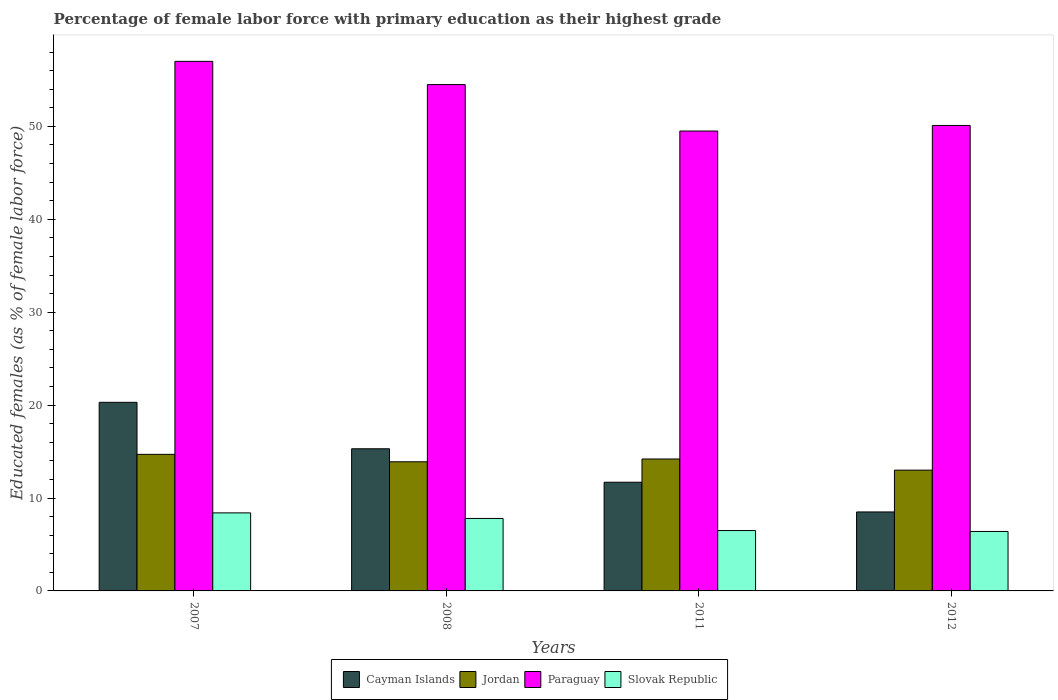How many different coloured bars are there?
Keep it short and to the point. 4. How many groups of bars are there?
Provide a succinct answer. 4. Are the number of bars per tick equal to the number of legend labels?
Provide a succinct answer. Yes. Are the number of bars on each tick of the X-axis equal?
Provide a succinct answer. Yes. How many bars are there on the 2nd tick from the left?
Provide a succinct answer. 4. In how many cases, is the number of bars for a given year not equal to the number of legend labels?
Your answer should be very brief. 0. Across all years, what is the maximum percentage of female labor force with primary education in Slovak Republic?
Your answer should be very brief. 8.4. Across all years, what is the minimum percentage of female labor force with primary education in Paraguay?
Ensure brevity in your answer.  49.5. In which year was the percentage of female labor force with primary education in Paraguay maximum?
Provide a succinct answer. 2007. What is the total percentage of female labor force with primary education in Slovak Republic in the graph?
Your response must be concise. 29.1. What is the difference between the percentage of female labor force with primary education in Jordan in 2007 and that in 2011?
Offer a very short reply. 0.5. What is the difference between the percentage of female labor force with primary education in Jordan in 2011 and the percentage of female labor force with primary education in Cayman Islands in 2007?
Your answer should be compact. -6.1. What is the average percentage of female labor force with primary education in Paraguay per year?
Offer a very short reply. 52.77. In the year 2007, what is the difference between the percentage of female labor force with primary education in Slovak Republic and percentage of female labor force with primary education in Paraguay?
Provide a succinct answer. -48.6. In how many years, is the percentage of female labor force with primary education in Jordan greater than 30 %?
Your answer should be very brief. 0. What is the ratio of the percentage of female labor force with primary education in Slovak Republic in 2008 to that in 2011?
Provide a succinct answer. 1.2. Is the percentage of female labor force with primary education in Slovak Republic in 2011 less than that in 2012?
Your response must be concise. No. Is the difference between the percentage of female labor force with primary education in Slovak Republic in 2007 and 2011 greater than the difference between the percentage of female labor force with primary education in Paraguay in 2007 and 2011?
Your answer should be compact. No. What is the difference between the highest and the second highest percentage of female labor force with primary education in Jordan?
Give a very brief answer. 0.5. What is the difference between the highest and the lowest percentage of female labor force with primary education in Slovak Republic?
Ensure brevity in your answer.  2. Is the sum of the percentage of female labor force with primary education in Slovak Republic in 2007 and 2008 greater than the maximum percentage of female labor force with primary education in Jordan across all years?
Your answer should be very brief. Yes. Is it the case that in every year, the sum of the percentage of female labor force with primary education in Slovak Republic and percentage of female labor force with primary education in Jordan is greater than the sum of percentage of female labor force with primary education in Paraguay and percentage of female labor force with primary education in Cayman Islands?
Provide a short and direct response. No. What does the 1st bar from the left in 2012 represents?
Give a very brief answer. Cayman Islands. What does the 3rd bar from the right in 2012 represents?
Your answer should be compact. Jordan. Is it the case that in every year, the sum of the percentage of female labor force with primary education in Paraguay and percentage of female labor force with primary education in Cayman Islands is greater than the percentage of female labor force with primary education in Slovak Republic?
Your answer should be very brief. Yes. Does the graph contain any zero values?
Offer a very short reply. No. What is the title of the graph?
Your answer should be very brief. Percentage of female labor force with primary education as their highest grade. Does "Philippines" appear as one of the legend labels in the graph?
Offer a very short reply. No. What is the label or title of the Y-axis?
Provide a short and direct response. Educated females (as % of female labor force). What is the Educated females (as % of female labor force) of Cayman Islands in 2007?
Keep it short and to the point. 20.3. What is the Educated females (as % of female labor force) in Jordan in 2007?
Your response must be concise. 14.7. What is the Educated females (as % of female labor force) in Paraguay in 2007?
Your answer should be compact. 57. What is the Educated females (as % of female labor force) in Slovak Republic in 2007?
Provide a short and direct response. 8.4. What is the Educated females (as % of female labor force) in Cayman Islands in 2008?
Your response must be concise. 15.3. What is the Educated females (as % of female labor force) of Jordan in 2008?
Offer a very short reply. 13.9. What is the Educated females (as % of female labor force) of Paraguay in 2008?
Give a very brief answer. 54.5. What is the Educated females (as % of female labor force) of Slovak Republic in 2008?
Offer a very short reply. 7.8. What is the Educated females (as % of female labor force) of Cayman Islands in 2011?
Your answer should be very brief. 11.7. What is the Educated females (as % of female labor force) of Jordan in 2011?
Offer a very short reply. 14.2. What is the Educated females (as % of female labor force) in Paraguay in 2011?
Your answer should be very brief. 49.5. What is the Educated females (as % of female labor force) of Slovak Republic in 2011?
Give a very brief answer. 6.5. What is the Educated females (as % of female labor force) of Jordan in 2012?
Ensure brevity in your answer.  13. What is the Educated females (as % of female labor force) of Paraguay in 2012?
Your answer should be compact. 50.1. What is the Educated females (as % of female labor force) in Slovak Republic in 2012?
Ensure brevity in your answer.  6.4. Across all years, what is the maximum Educated females (as % of female labor force) of Cayman Islands?
Provide a succinct answer. 20.3. Across all years, what is the maximum Educated females (as % of female labor force) in Jordan?
Your answer should be compact. 14.7. Across all years, what is the maximum Educated females (as % of female labor force) of Slovak Republic?
Provide a short and direct response. 8.4. Across all years, what is the minimum Educated females (as % of female labor force) in Paraguay?
Keep it short and to the point. 49.5. Across all years, what is the minimum Educated females (as % of female labor force) of Slovak Republic?
Your answer should be compact. 6.4. What is the total Educated females (as % of female labor force) in Cayman Islands in the graph?
Offer a very short reply. 55.8. What is the total Educated females (as % of female labor force) in Jordan in the graph?
Keep it short and to the point. 55.8. What is the total Educated females (as % of female labor force) of Paraguay in the graph?
Provide a succinct answer. 211.1. What is the total Educated females (as % of female labor force) in Slovak Republic in the graph?
Ensure brevity in your answer.  29.1. What is the difference between the Educated females (as % of female labor force) of Paraguay in 2007 and that in 2008?
Provide a short and direct response. 2.5. What is the difference between the Educated females (as % of female labor force) of Cayman Islands in 2007 and that in 2011?
Your answer should be very brief. 8.6. What is the difference between the Educated females (as % of female labor force) of Jordan in 2007 and that in 2011?
Keep it short and to the point. 0.5. What is the difference between the Educated females (as % of female labor force) in Paraguay in 2007 and that in 2011?
Your answer should be compact. 7.5. What is the difference between the Educated females (as % of female labor force) of Jordan in 2007 and that in 2012?
Keep it short and to the point. 1.7. What is the difference between the Educated females (as % of female labor force) in Jordan in 2008 and that in 2011?
Ensure brevity in your answer.  -0.3. What is the difference between the Educated females (as % of female labor force) in Paraguay in 2008 and that in 2011?
Ensure brevity in your answer.  5. What is the difference between the Educated females (as % of female labor force) of Slovak Republic in 2008 and that in 2011?
Make the answer very short. 1.3. What is the difference between the Educated females (as % of female labor force) of Slovak Republic in 2008 and that in 2012?
Keep it short and to the point. 1.4. What is the difference between the Educated females (as % of female labor force) of Cayman Islands in 2011 and that in 2012?
Provide a succinct answer. 3.2. What is the difference between the Educated females (as % of female labor force) in Slovak Republic in 2011 and that in 2012?
Your answer should be very brief. 0.1. What is the difference between the Educated females (as % of female labor force) of Cayman Islands in 2007 and the Educated females (as % of female labor force) of Jordan in 2008?
Make the answer very short. 6.4. What is the difference between the Educated females (as % of female labor force) of Cayman Islands in 2007 and the Educated females (as % of female labor force) of Paraguay in 2008?
Provide a short and direct response. -34.2. What is the difference between the Educated females (as % of female labor force) in Jordan in 2007 and the Educated females (as % of female labor force) in Paraguay in 2008?
Ensure brevity in your answer.  -39.8. What is the difference between the Educated females (as % of female labor force) in Paraguay in 2007 and the Educated females (as % of female labor force) in Slovak Republic in 2008?
Provide a succinct answer. 49.2. What is the difference between the Educated females (as % of female labor force) of Cayman Islands in 2007 and the Educated females (as % of female labor force) of Paraguay in 2011?
Provide a short and direct response. -29.2. What is the difference between the Educated females (as % of female labor force) in Jordan in 2007 and the Educated females (as % of female labor force) in Paraguay in 2011?
Provide a succinct answer. -34.8. What is the difference between the Educated females (as % of female labor force) in Jordan in 2007 and the Educated females (as % of female labor force) in Slovak Republic in 2011?
Provide a short and direct response. 8.2. What is the difference between the Educated females (as % of female labor force) in Paraguay in 2007 and the Educated females (as % of female labor force) in Slovak Republic in 2011?
Your answer should be very brief. 50.5. What is the difference between the Educated females (as % of female labor force) of Cayman Islands in 2007 and the Educated females (as % of female labor force) of Jordan in 2012?
Your response must be concise. 7.3. What is the difference between the Educated females (as % of female labor force) in Cayman Islands in 2007 and the Educated females (as % of female labor force) in Paraguay in 2012?
Your answer should be very brief. -29.8. What is the difference between the Educated females (as % of female labor force) of Cayman Islands in 2007 and the Educated females (as % of female labor force) of Slovak Republic in 2012?
Give a very brief answer. 13.9. What is the difference between the Educated females (as % of female labor force) in Jordan in 2007 and the Educated females (as % of female labor force) in Paraguay in 2012?
Your answer should be very brief. -35.4. What is the difference between the Educated females (as % of female labor force) in Jordan in 2007 and the Educated females (as % of female labor force) in Slovak Republic in 2012?
Make the answer very short. 8.3. What is the difference between the Educated females (as % of female labor force) of Paraguay in 2007 and the Educated females (as % of female labor force) of Slovak Republic in 2012?
Keep it short and to the point. 50.6. What is the difference between the Educated females (as % of female labor force) of Cayman Islands in 2008 and the Educated females (as % of female labor force) of Paraguay in 2011?
Offer a very short reply. -34.2. What is the difference between the Educated females (as % of female labor force) of Cayman Islands in 2008 and the Educated females (as % of female labor force) of Slovak Republic in 2011?
Give a very brief answer. 8.8. What is the difference between the Educated females (as % of female labor force) in Jordan in 2008 and the Educated females (as % of female labor force) in Paraguay in 2011?
Provide a short and direct response. -35.6. What is the difference between the Educated females (as % of female labor force) in Cayman Islands in 2008 and the Educated females (as % of female labor force) in Paraguay in 2012?
Offer a terse response. -34.8. What is the difference between the Educated females (as % of female labor force) of Jordan in 2008 and the Educated females (as % of female labor force) of Paraguay in 2012?
Keep it short and to the point. -36.2. What is the difference between the Educated females (as % of female labor force) of Jordan in 2008 and the Educated females (as % of female labor force) of Slovak Republic in 2012?
Give a very brief answer. 7.5. What is the difference between the Educated females (as % of female labor force) of Paraguay in 2008 and the Educated females (as % of female labor force) of Slovak Republic in 2012?
Ensure brevity in your answer.  48.1. What is the difference between the Educated females (as % of female labor force) of Cayman Islands in 2011 and the Educated females (as % of female labor force) of Paraguay in 2012?
Provide a succinct answer. -38.4. What is the difference between the Educated females (as % of female labor force) of Jordan in 2011 and the Educated females (as % of female labor force) of Paraguay in 2012?
Offer a very short reply. -35.9. What is the difference between the Educated females (as % of female labor force) in Jordan in 2011 and the Educated females (as % of female labor force) in Slovak Republic in 2012?
Ensure brevity in your answer.  7.8. What is the difference between the Educated females (as % of female labor force) in Paraguay in 2011 and the Educated females (as % of female labor force) in Slovak Republic in 2012?
Provide a succinct answer. 43.1. What is the average Educated females (as % of female labor force) in Cayman Islands per year?
Your answer should be very brief. 13.95. What is the average Educated females (as % of female labor force) of Jordan per year?
Offer a very short reply. 13.95. What is the average Educated females (as % of female labor force) in Paraguay per year?
Ensure brevity in your answer.  52.77. What is the average Educated females (as % of female labor force) in Slovak Republic per year?
Your answer should be compact. 7.28. In the year 2007, what is the difference between the Educated females (as % of female labor force) of Cayman Islands and Educated females (as % of female labor force) of Jordan?
Provide a succinct answer. 5.6. In the year 2007, what is the difference between the Educated females (as % of female labor force) of Cayman Islands and Educated females (as % of female labor force) of Paraguay?
Give a very brief answer. -36.7. In the year 2007, what is the difference between the Educated females (as % of female labor force) of Jordan and Educated females (as % of female labor force) of Paraguay?
Your answer should be compact. -42.3. In the year 2007, what is the difference between the Educated females (as % of female labor force) in Paraguay and Educated females (as % of female labor force) in Slovak Republic?
Give a very brief answer. 48.6. In the year 2008, what is the difference between the Educated females (as % of female labor force) in Cayman Islands and Educated females (as % of female labor force) in Paraguay?
Offer a terse response. -39.2. In the year 2008, what is the difference between the Educated females (as % of female labor force) of Cayman Islands and Educated females (as % of female labor force) of Slovak Republic?
Your answer should be very brief. 7.5. In the year 2008, what is the difference between the Educated females (as % of female labor force) in Jordan and Educated females (as % of female labor force) in Paraguay?
Your answer should be compact. -40.6. In the year 2008, what is the difference between the Educated females (as % of female labor force) of Paraguay and Educated females (as % of female labor force) of Slovak Republic?
Give a very brief answer. 46.7. In the year 2011, what is the difference between the Educated females (as % of female labor force) in Cayman Islands and Educated females (as % of female labor force) in Jordan?
Offer a terse response. -2.5. In the year 2011, what is the difference between the Educated females (as % of female labor force) in Cayman Islands and Educated females (as % of female labor force) in Paraguay?
Ensure brevity in your answer.  -37.8. In the year 2011, what is the difference between the Educated females (as % of female labor force) in Cayman Islands and Educated females (as % of female labor force) in Slovak Republic?
Give a very brief answer. 5.2. In the year 2011, what is the difference between the Educated females (as % of female labor force) in Jordan and Educated females (as % of female labor force) in Paraguay?
Provide a short and direct response. -35.3. In the year 2011, what is the difference between the Educated females (as % of female labor force) in Jordan and Educated females (as % of female labor force) in Slovak Republic?
Offer a terse response. 7.7. In the year 2011, what is the difference between the Educated females (as % of female labor force) in Paraguay and Educated females (as % of female labor force) in Slovak Republic?
Provide a succinct answer. 43. In the year 2012, what is the difference between the Educated females (as % of female labor force) in Cayman Islands and Educated females (as % of female labor force) in Jordan?
Keep it short and to the point. -4.5. In the year 2012, what is the difference between the Educated females (as % of female labor force) in Cayman Islands and Educated females (as % of female labor force) in Paraguay?
Offer a very short reply. -41.6. In the year 2012, what is the difference between the Educated females (as % of female labor force) of Jordan and Educated females (as % of female labor force) of Paraguay?
Give a very brief answer. -37.1. In the year 2012, what is the difference between the Educated females (as % of female labor force) in Paraguay and Educated females (as % of female labor force) in Slovak Republic?
Offer a very short reply. 43.7. What is the ratio of the Educated females (as % of female labor force) in Cayman Islands in 2007 to that in 2008?
Your answer should be compact. 1.33. What is the ratio of the Educated females (as % of female labor force) of Jordan in 2007 to that in 2008?
Provide a short and direct response. 1.06. What is the ratio of the Educated females (as % of female labor force) in Paraguay in 2007 to that in 2008?
Ensure brevity in your answer.  1.05. What is the ratio of the Educated females (as % of female labor force) of Cayman Islands in 2007 to that in 2011?
Keep it short and to the point. 1.74. What is the ratio of the Educated females (as % of female labor force) of Jordan in 2007 to that in 2011?
Your answer should be compact. 1.04. What is the ratio of the Educated females (as % of female labor force) in Paraguay in 2007 to that in 2011?
Offer a terse response. 1.15. What is the ratio of the Educated females (as % of female labor force) of Slovak Republic in 2007 to that in 2011?
Keep it short and to the point. 1.29. What is the ratio of the Educated females (as % of female labor force) of Cayman Islands in 2007 to that in 2012?
Your response must be concise. 2.39. What is the ratio of the Educated females (as % of female labor force) of Jordan in 2007 to that in 2012?
Give a very brief answer. 1.13. What is the ratio of the Educated females (as % of female labor force) in Paraguay in 2007 to that in 2012?
Provide a short and direct response. 1.14. What is the ratio of the Educated females (as % of female labor force) of Slovak Republic in 2007 to that in 2012?
Your answer should be compact. 1.31. What is the ratio of the Educated females (as % of female labor force) of Cayman Islands in 2008 to that in 2011?
Your answer should be very brief. 1.31. What is the ratio of the Educated females (as % of female labor force) of Jordan in 2008 to that in 2011?
Give a very brief answer. 0.98. What is the ratio of the Educated females (as % of female labor force) in Paraguay in 2008 to that in 2011?
Offer a terse response. 1.1. What is the ratio of the Educated females (as % of female labor force) of Jordan in 2008 to that in 2012?
Provide a short and direct response. 1.07. What is the ratio of the Educated females (as % of female labor force) in Paraguay in 2008 to that in 2012?
Offer a very short reply. 1.09. What is the ratio of the Educated females (as % of female labor force) of Slovak Republic in 2008 to that in 2012?
Your response must be concise. 1.22. What is the ratio of the Educated females (as % of female labor force) of Cayman Islands in 2011 to that in 2012?
Provide a short and direct response. 1.38. What is the ratio of the Educated females (as % of female labor force) in Jordan in 2011 to that in 2012?
Provide a succinct answer. 1.09. What is the ratio of the Educated females (as % of female labor force) in Paraguay in 2011 to that in 2012?
Give a very brief answer. 0.99. What is the ratio of the Educated females (as % of female labor force) in Slovak Republic in 2011 to that in 2012?
Give a very brief answer. 1.02. What is the difference between the highest and the second highest Educated females (as % of female labor force) in Cayman Islands?
Your answer should be very brief. 5. What is the difference between the highest and the second highest Educated females (as % of female labor force) in Jordan?
Provide a short and direct response. 0.5. What is the difference between the highest and the second highest Educated females (as % of female labor force) of Paraguay?
Ensure brevity in your answer.  2.5. What is the difference between the highest and the second highest Educated females (as % of female labor force) of Slovak Republic?
Provide a short and direct response. 0.6. What is the difference between the highest and the lowest Educated females (as % of female labor force) in Cayman Islands?
Keep it short and to the point. 11.8. What is the difference between the highest and the lowest Educated females (as % of female labor force) in Jordan?
Give a very brief answer. 1.7. 